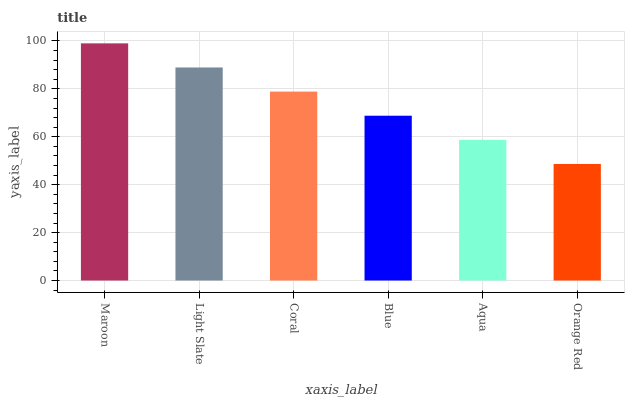Is Orange Red the minimum?
Answer yes or no. Yes. Is Maroon the maximum?
Answer yes or no. Yes. Is Light Slate the minimum?
Answer yes or no. No. Is Light Slate the maximum?
Answer yes or no. No. Is Maroon greater than Light Slate?
Answer yes or no. Yes. Is Light Slate less than Maroon?
Answer yes or no. Yes. Is Light Slate greater than Maroon?
Answer yes or no. No. Is Maroon less than Light Slate?
Answer yes or no. No. Is Coral the high median?
Answer yes or no. Yes. Is Blue the low median?
Answer yes or no. Yes. Is Light Slate the high median?
Answer yes or no. No. Is Coral the low median?
Answer yes or no. No. 